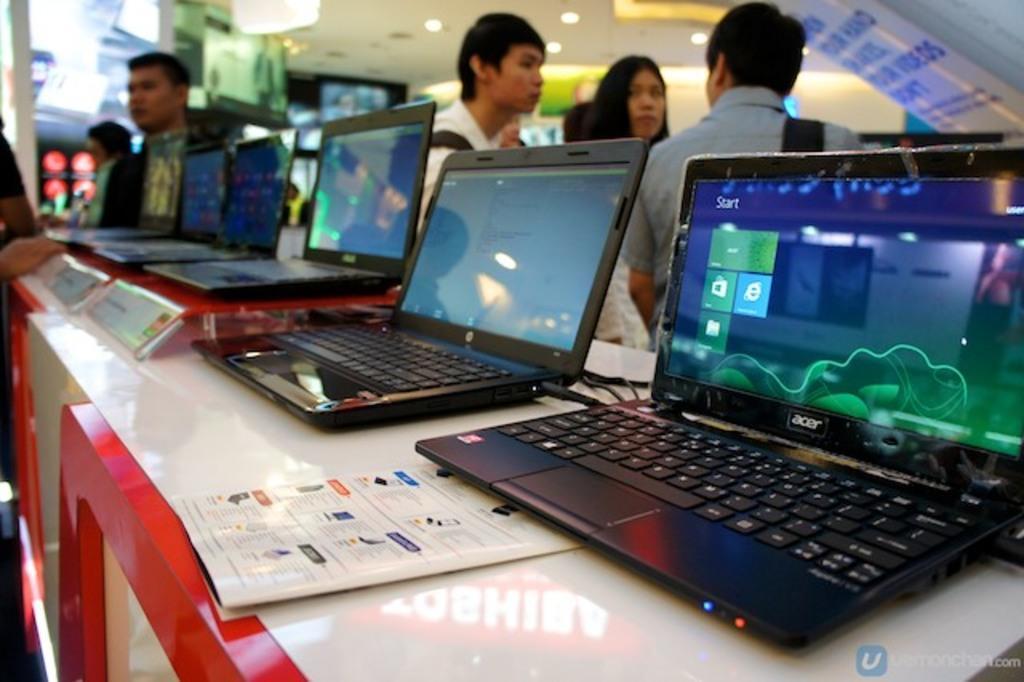In one or two sentences, can you explain what this image depicts? In this image in the center there are laptops on the table. In the background there are persons, there are monitors and there are lights. 